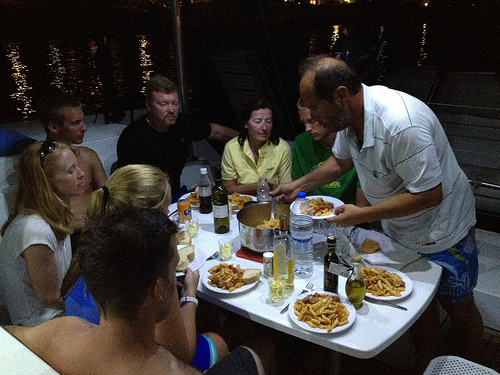What types of food can be spotted in the image? The table is laid with various informal dining foods including what looks like plates piled with French fries, possibly some burger buns, and a few bottles that may contain condiments or beverages. 